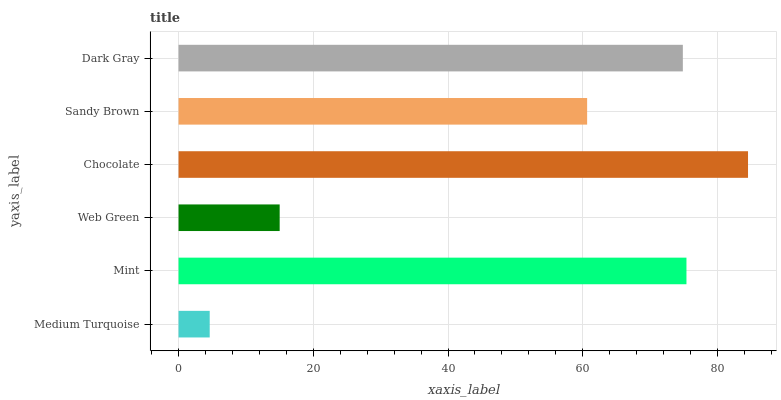Is Medium Turquoise the minimum?
Answer yes or no. Yes. Is Chocolate the maximum?
Answer yes or no. Yes. Is Mint the minimum?
Answer yes or no. No. Is Mint the maximum?
Answer yes or no. No. Is Mint greater than Medium Turquoise?
Answer yes or no. Yes. Is Medium Turquoise less than Mint?
Answer yes or no. Yes. Is Medium Turquoise greater than Mint?
Answer yes or no. No. Is Mint less than Medium Turquoise?
Answer yes or no. No. Is Dark Gray the high median?
Answer yes or no. Yes. Is Sandy Brown the low median?
Answer yes or no. Yes. Is Medium Turquoise the high median?
Answer yes or no. No. Is Web Green the low median?
Answer yes or no. No. 